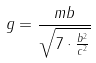Convert formula to latex. <formula><loc_0><loc_0><loc_500><loc_500>g = \frac { m b } { \sqrt { 7 \cdot \frac { b ^ { 2 } } { c ^ { 2 } } } }</formula> 